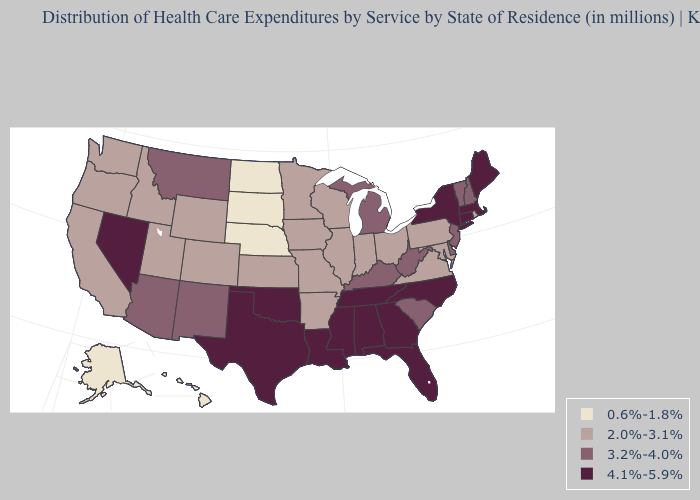Name the states that have a value in the range 0.6%-1.8%?
Give a very brief answer. Alaska, Hawaii, Nebraska, North Dakota, South Dakota. Among the states that border Wyoming , does Montana have the highest value?
Short answer required. Yes. Which states have the highest value in the USA?
Keep it brief. Alabama, Connecticut, Florida, Georgia, Louisiana, Maine, Massachusetts, Mississippi, Nevada, New York, North Carolina, Oklahoma, Tennessee, Texas. Name the states that have a value in the range 0.6%-1.8%?
Quick response, please. Alaska, Hawaii, Nebraska, North Dakota, South Dakota. Name the states that have a value in the range 0.6%-1.8%?
Give a very brief answer. Alaska, Hawaii, Nebraska, North Dakota, South Dakota. Does Alaska have the lowest value in the West?
Give a very brief answer. Yes. Name the states that have a value in the range 2.0%-3.1%?
Keep it brief. Arkansas, California, Colorado, Idaho, Illinois, Indiana, Iowa, Kansas, Maryland, Minnesota, Missouri, Ohio, Oregon, Pennsylvania, Rhode Island, Utah, Virginia, Washington, Wisconsin, Wyoming. What is the lowest value in the MidWest?
Give a very brief answer. 0.6%-1.8%. Does Texas have the highest value in the USA?
Quick response, please. Yes. Name the states that have a value in the range 2.0%-3.1%?
Write a very short answer. Arkansas, California, Colorado, Idaho, Illinois, Indiana, Iowa, Kansas, Maryland, Minnesota, Missouri, Ohio, Oregon, Pennsylvania, Rhode Island, Utah, Virginia, Washington, Wisconsin, Wyoming. Among the states that border South Dakota , which have the lowest value?
Short answer required. Nebraska, North Dakota. What is the highest value in the USA?
Be succinct. 4.1%-5.9%. Is the legend a continuous bar?
Keep it brief. No. How many symbols are there in the legend?
Short answer required. 4. What is the value of New York?
Quick response, please. 4.1%-5.9%. 